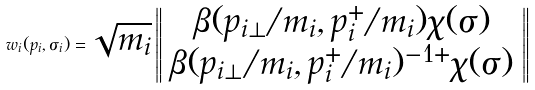<formula> <loc_0><loc_0><loc_500><loc_500>w _ { i } ( p _ { i } , \sigma _ { i } ) = \sqrt { m _ { i } } \left \| \begin{array} { c } \beta ( { p } _ { i \bot } / m _ { i } , p _ { i } ^ { + } / m _ { i } ) \chi ( \sigma ) \\ \beta ( { p } _ { i \bot } / m _ { i } , p _ { i } ^ { + } / m _ { i } ) ^ { - 1 + } \chi ( \sigma ) \end{array} \right \|</formula> 